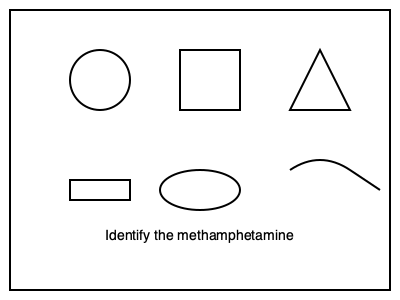Based on your law enforcement training, which shape in the image most likely represents crystalline methamphetamine? 1. Circle: This shape is typically associated with pills or tablets, not crystalline substances.
2. Square: While some drugs may come in square-pressed forms, this is not characteristic of methamphetamine.
3. Triangle: This shape is not commonly associated with any specific drug form.
4. Rectangle: This could represent a drug baggie, but not the substance itself.
5. Oval: Similar to the circle, this shape is more indicative of pills or capsules.
6. Wavy line: This could represent a liquid form, which is not typical for methamphetamine.
7. Irregular crystal shape (not shown): Methamphetamine often appears as clear, crystal-like shards.

The question specifically asks about crystalline methamphetamine. Among the given shapes, none accurately represent the typical appearance of crystal meth. However, the shape that most closely resembles the irregular, shard-like structure of crystalline methamphetamine would be the triangle, as it has sharp edges and a pointed structure.
Answer: Triangle 